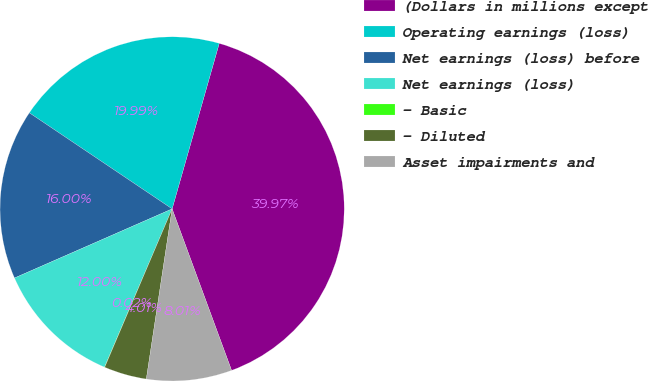<chart> <loc_0><loc_0><loc_500><loc_500><pie_chart><fcel>(Dollars in millions except<fcel>Operating earnings (loss)<fcel>Net earnings (loss) before<fcel>Net earnings (loss)<fcel>- Basic<fcel>- Diluted<fcel>Asset impairments and<nl><fcel>39.97%<fcel>19.99%<fcel>16.0%<fcel>12.0%<fcel>0.02%<fcel>4.01%<fcel>8.01%<nl></chart> 